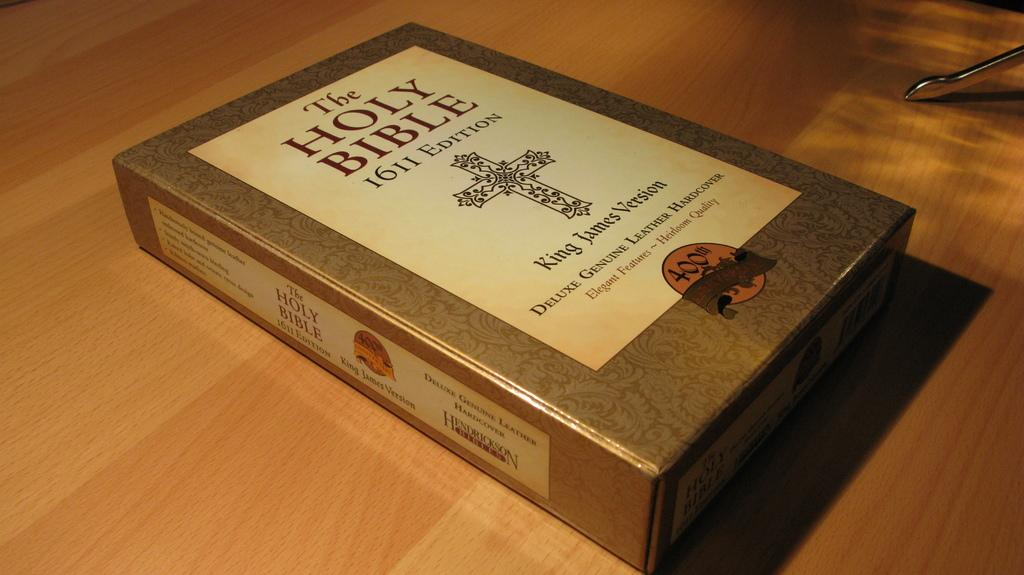What is the main object in the image? There is a box in the image. Where is the box located? The box is placed on a wooden surface. What can be seen on the box? There is text on the box. Can you describe the object in the top right-hand corner of the image? There is a metal object in the top right-hand corner of the image. What type of insurance policy is the father discussing in the image? There is no father or discussion of insurance policies present in the image; it features a box on a wooden surface with text and a metal object in the top right-hand corner. 